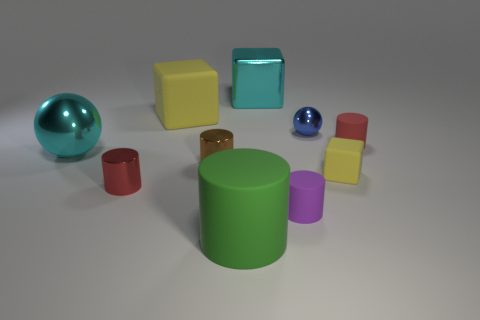Subtract all green cylinders. How many cylinders are left? 4 Subtract all cyan cubes. How many cubes are left? 2 Subtract all cubes. How many objects are left? 7 Subtract 2 spheres. How many spheres are left? 0 Subtract all blue cylinders. Subtract all brown spheres. How many cylinders are left? 5 Subtract all brown cylinders. How many cyan balls are left? 1 Subtract all large cyan spheres. Subtract all small metal cylinders. How many objects are left? 7 Add 4 tiny yellow matte cubes. How many tiny yellow matte cubes are left? 5 Add 8 small rubber cubes. How many small rubber cubes exist? 9 Subtract 0 blue cylinders. How many objects are left? 10 